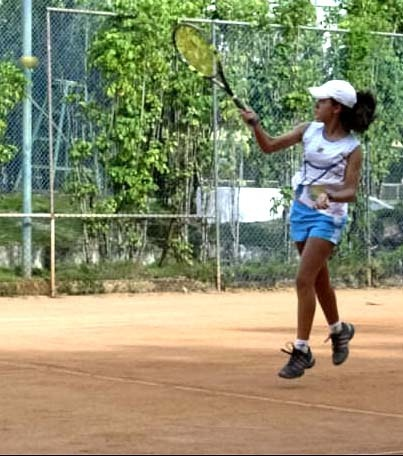Describe the objects in this image and their specific colors. I can see people in beige, black, maroon, gray, and white tones, tennis racket in beige, olive, darkgreen, and black tones, sports ball in beige, khaki, and olive tones, and sports ball in beige, olive, gray, and khaki tones in this image. 